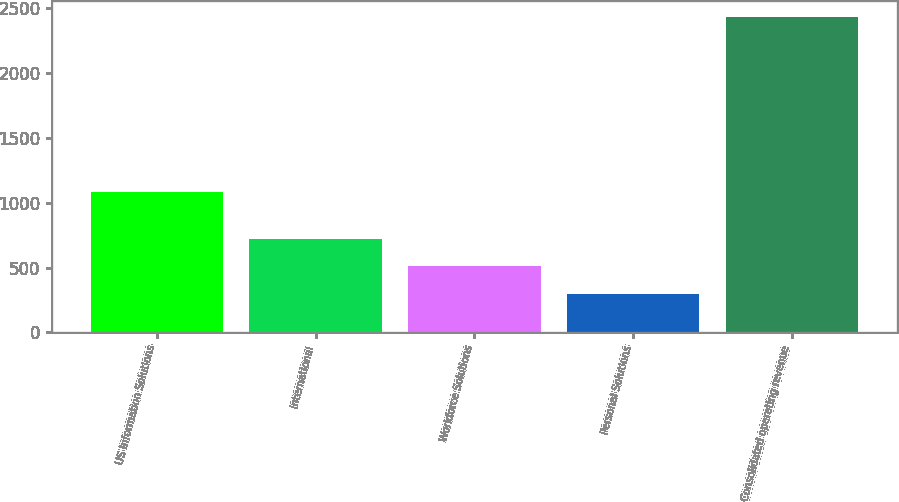Convert chart to OTSL. <chart><loc_0><loc_0><loc_500><loc_500><bar_chart><fcel>US Information Solutions<fcel>International<fcel>Workforce Solutions<fcel>Personal Solutions<fcel>Consolidated operating revenue<nl><fcel>1079.9<fcel>722.64<fcel>508.42<fcel>294.2<fcel>2436.4<nl></chart> 